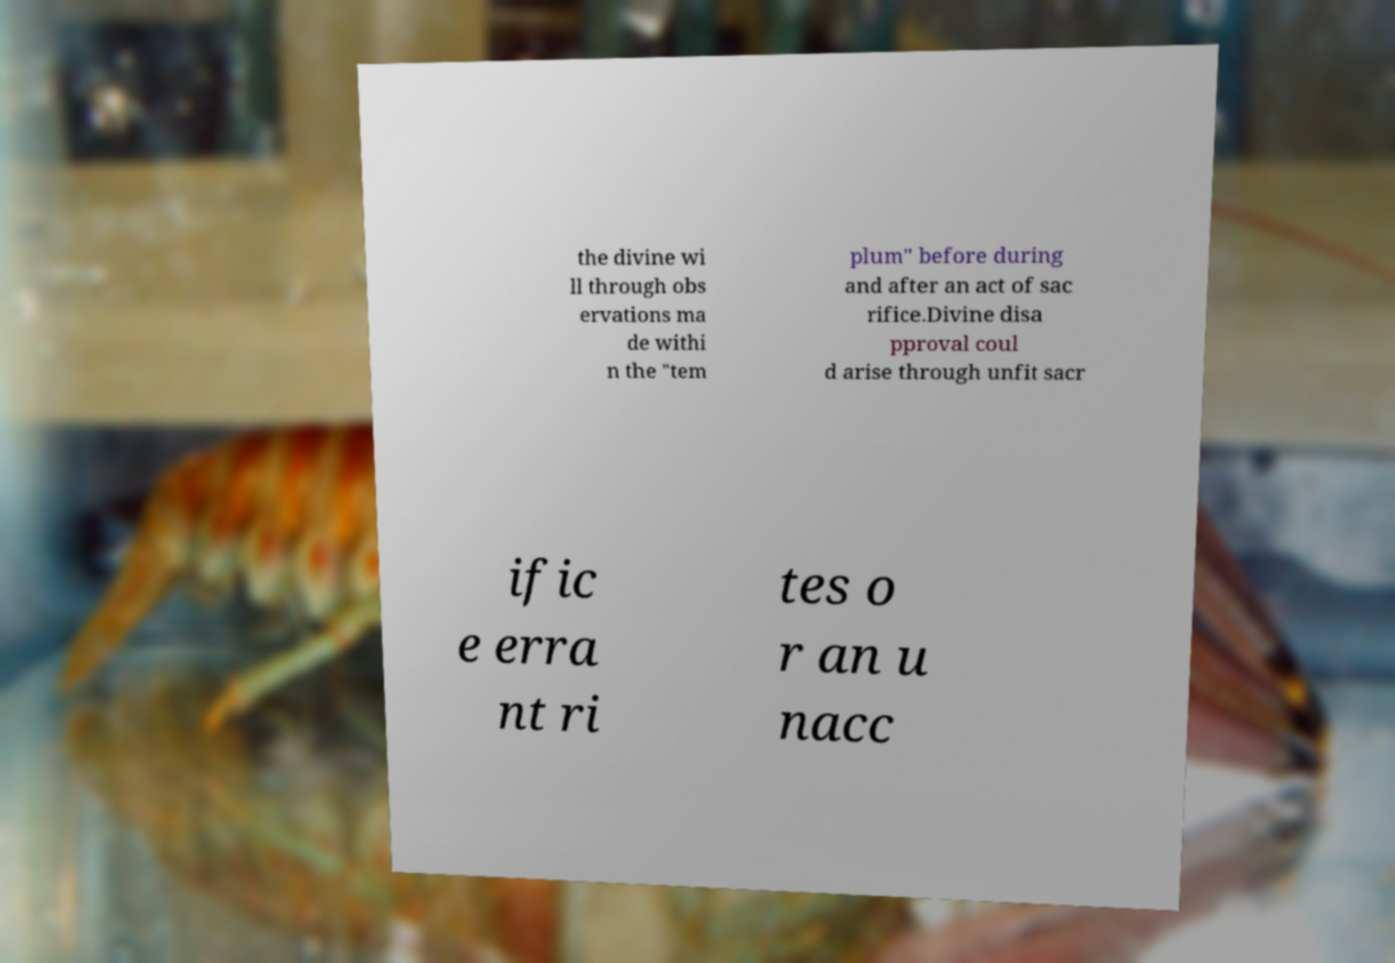I need the written content from this picture converted into text. Can you do that? the divine wi ll through obs ervations ma de withi n the "tem plum" before during and after an act of sac rifice.Divine disa pproval coul d arise through unfit sacr ific e erra nt ri tes o r an u nacc 